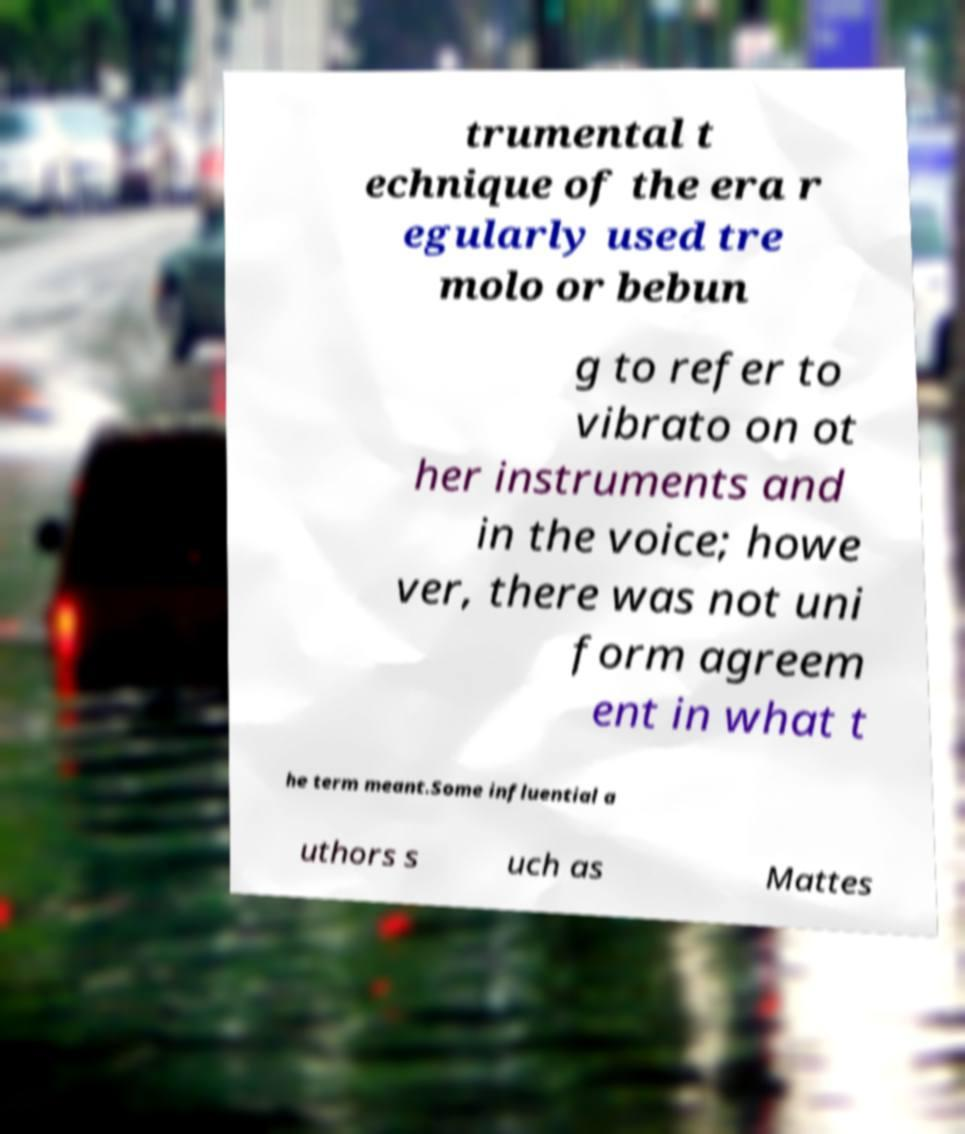Please identify and transcribe the text found in this image. trumental t echnique of the era r egularly used tre molo or bebun g to refer to vibrato on ot her instruments and in the voice; howe ver, there was not uni form agreem ent in what t he term meant.Some influential a uthors s uch as Mattes 